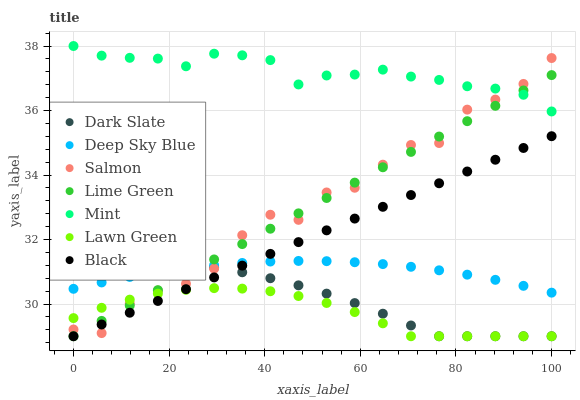Does Lawn Green have the minimum area under the curve?
Answer yes or no. Yes. Does Mint have the maximum area under the curve?
Answer yes or no. Yes. Does Salmon have the minimum area under the curve?
Answer yes or no. No. Does Salmon have the maximum area under the curve?
Answer yes or no. No. Is Lime Green the smoothest?
Answer yes or no. Yes. Is Salmon the roughest?
Answer yes or no. Yes. Is Mint the smoothest?
Answer yes or no. No. Is Mint the roughest?
Answer yes or no. No. Does Lawn Green have the lowest value?
Answer yes or no. Yes. Does Salmon have the lowest value?
Answer yes or no. No. Does Mint have the highest value?
Answer yes or no. Yes. Does Salmon have the highest value?
Answer yes or no. No. Is Deep Sky Blue less than Mint?
Answer yes or no. Yes. Is Mint greater than Black?
Answer yes or no. Yes. Does Dark Slate intersect Lawn Green?
Answer yes or no. Yes. Is Dark Slate less than Lawn Green?
Answer yes or no. No. Is Dark Slate greater than Lawn Green?
Answer yes or no. No. Does Deep Sky Blue intersect Mint?
Answer yes or no. No. 